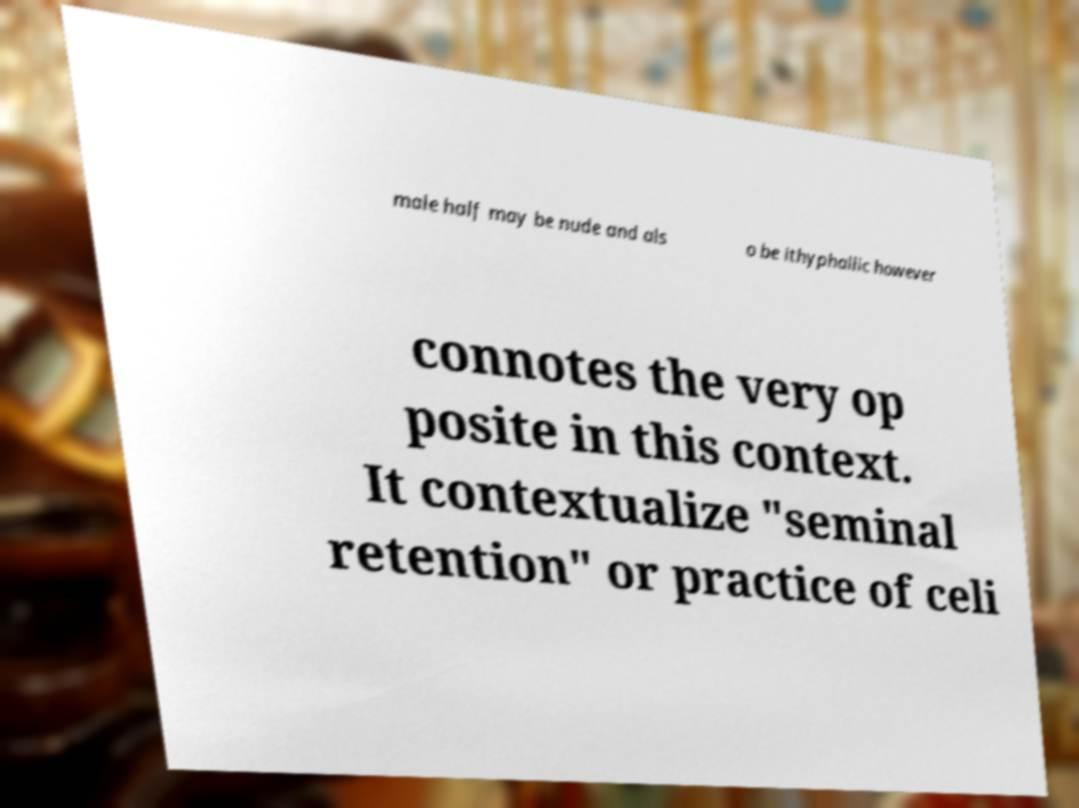For documentation purposes, I need the text within this image transcribed. Could you provide that? male half may be nude and als o be ithyphallic however connotes the very op posite in this context. It contextualize "seminal retention" or practice of celi 